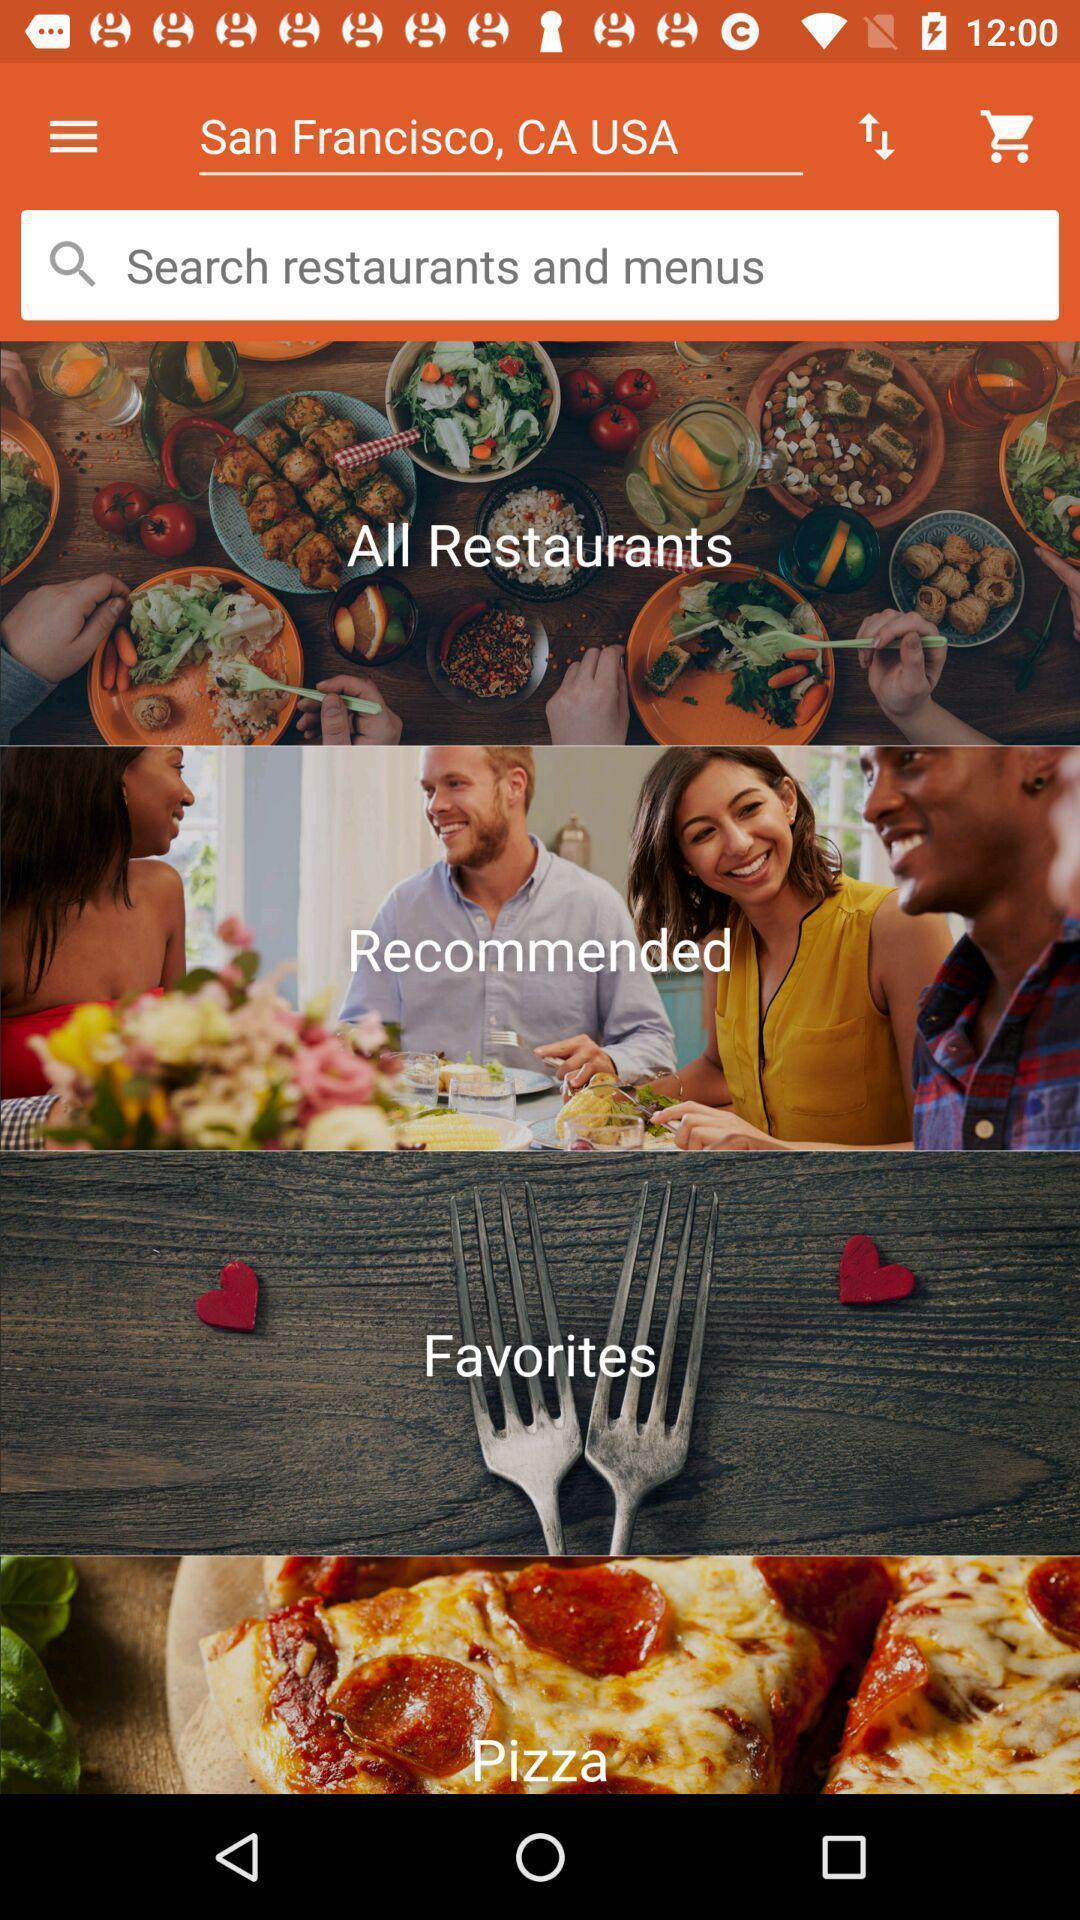Describe this image in words. Search page for the food app. 